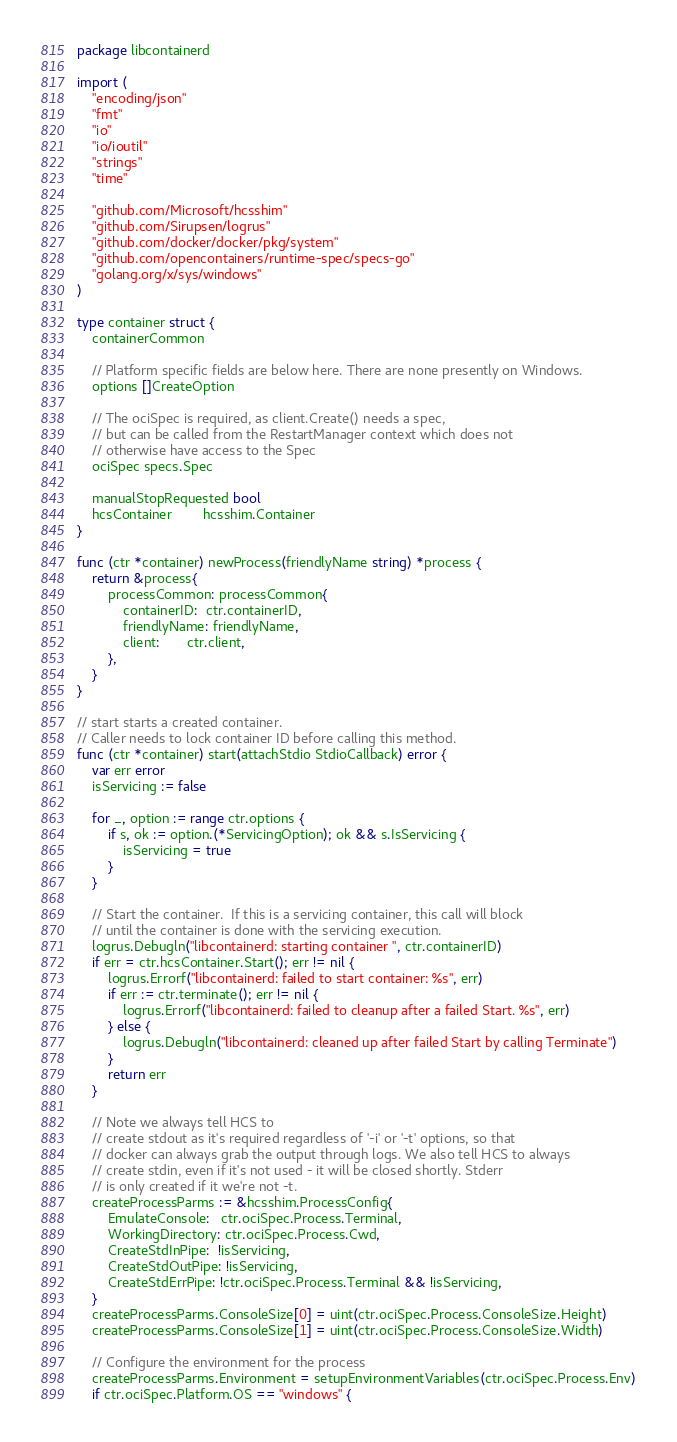Convert code to text. <code><loc_0><loc_0><loc_500><loc_500><_Go_>package libcontainerd

import (
	"encoding/json"
	"fmt"
	"io"
	"io/ioutil"
	"strings"
	"time"

	"github.com/Microsoft/hcsshim"
	"github.com/Sirupsen/logrus"
	"github.com/docker/docker/pkg/system"
	"github.com/opencontainers/runtime-spec/specs-go"
	"golang.org/x/sys/windows"
)

type container struct {
	containerCommon

	// Platform specific fields are below here. There are none presently on Windows.
	options []CreateOption

	// The ociSpec is required, as client.Create() needs a spec,
	// but can be called from the RestartManager context which does not
	// otherwise have access to the Spec
	ociSpec specs.Spec

	manualStopRequested bool
	hcsContainer        hcsshim.Container
}

func (ctr *container) newProcess(friendlyName string) *process {
	return &process{
		processCommon: processCommon{
			containerID:  ctr.containerID,
			friendlyName: friendlyName,
			client:       ctr.client,
		},
	}
}

// start starts a created container.
// Caller needs to lock container ID before calling this method.
func (ctr *container) start(attachStdio StdioCallback) error {
	var err error
	isServicing := false

	for _, option := range ctr.options {
		if s, ok := option.(*ServicingOption); ok && s.IsServicing {
			isServicing = true
		}
	}

	// Start the container.  If this is a servicing container, this call will block
	// until the container is done with the servicing execution.
	logrus.Debugln("libcontainerd: starting container ", ctr.containerID)
	if err = ctr.hcsContainer.Start(); err != nil {
		logrus.Errorf("libcontainerd: failed to start container: %s", err)
		if err := ctr.terminate(); err != nil {
			logrus.Errorf("libcontainerd: failed to cleanup after a failed Start. %s", err)
		} else {
			logrus.Debugln("libcontainerd: cleaned up after failed Start by calling Terminate")
		}
		return err
	}

	// Note we always tell HCS to
	// create stdout as it's required regardless of '-i' or '-t' options, so that
	// docker can always grab the output through logs. We also tell HCS to always
	// create stdin, even if it's not used - it will be closed shortly. Stderr
	// is only created if it we're not -t.
	createProcessParms := &hcsshim.ProcessConfig{
		EmulateConsole:   ctr.ociSpec.Process.Terminal,
		WorkingDirectory: ctr.ociSpec.Process.Cwd,
		CreateStdInPipe:  !isServicing,
		CreateStdOutPipe: !isServicing,
		CreateStdErrPipe: !ctr.ociSpec.Process.Terminal && !isServicing,
	}
	createProcessParms.ConsoleSize[0] = uint(ctr.ociSpec.Process.ConsoleSize.Height)
	createProcessParms.ConsoleSize[1] = uint(ctr.ociSpec.Process.ConsoleSize.Width)

	// Configure the environment for the process
	createProcessParms.Environment = setupEnvironmentVariables(ctr.ociSpec.Process.Env)
	if ctr.ociSpec.Platform.OS == "windows" {</code> 